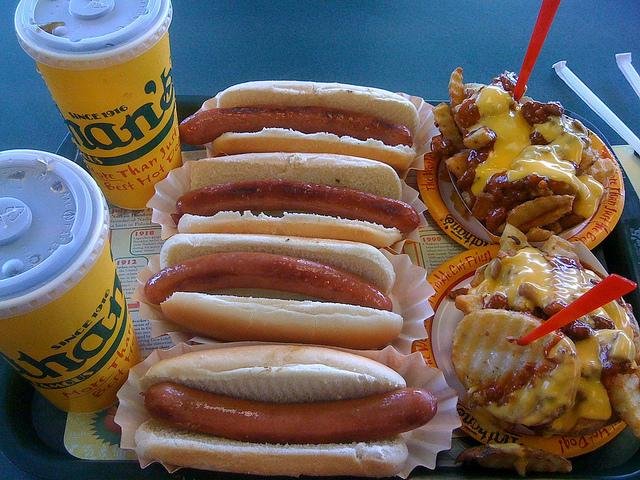What annual event is the company famous for?

Choices:
A) butchering contest
B) barbecue contest
C) eating contest
D) cooking contest eating contest 